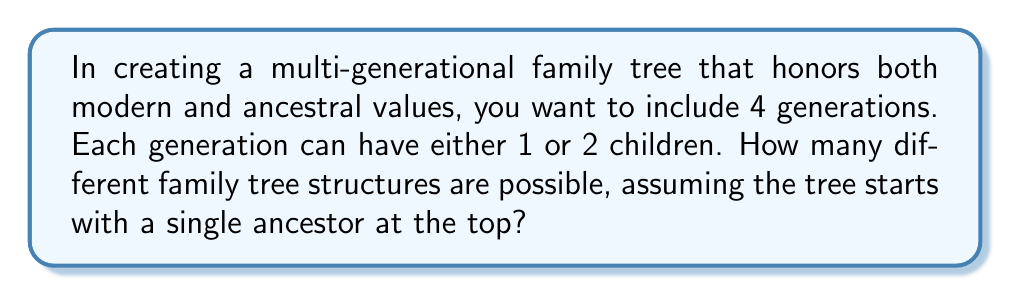Can you answer this question? Let's approach this step-by-step:

1) We start with a single ancestor at the top (1st generation).

2) For each subsequent generation, we have two choices: 1 child or 2 children.

3) We need to make this choice for 3 generations (2nd, 3rd, and 4th generations).

4) This scenario can be modeled as a sequence of 3 independent choices, where each choice has 2 options.

5) The number of possible outcomes for a sequence of independent events is the product of the number of possibilities for each event.

6) In this case, we have:
   $$ 2 \times 2 \times 2 = 2^3 $$

7) We can also think of this as filling 3 positions (one for each generation's choice) with 2 options each:
   $$ \text{Total combinations} = 2^3 = 8 $$

This approach allows for a balance between modern family structures (which might include single-child families) and ancestral values (which might favor larger families), reflecting the dual identity mentioned in the persona.
Answer: $8$ 